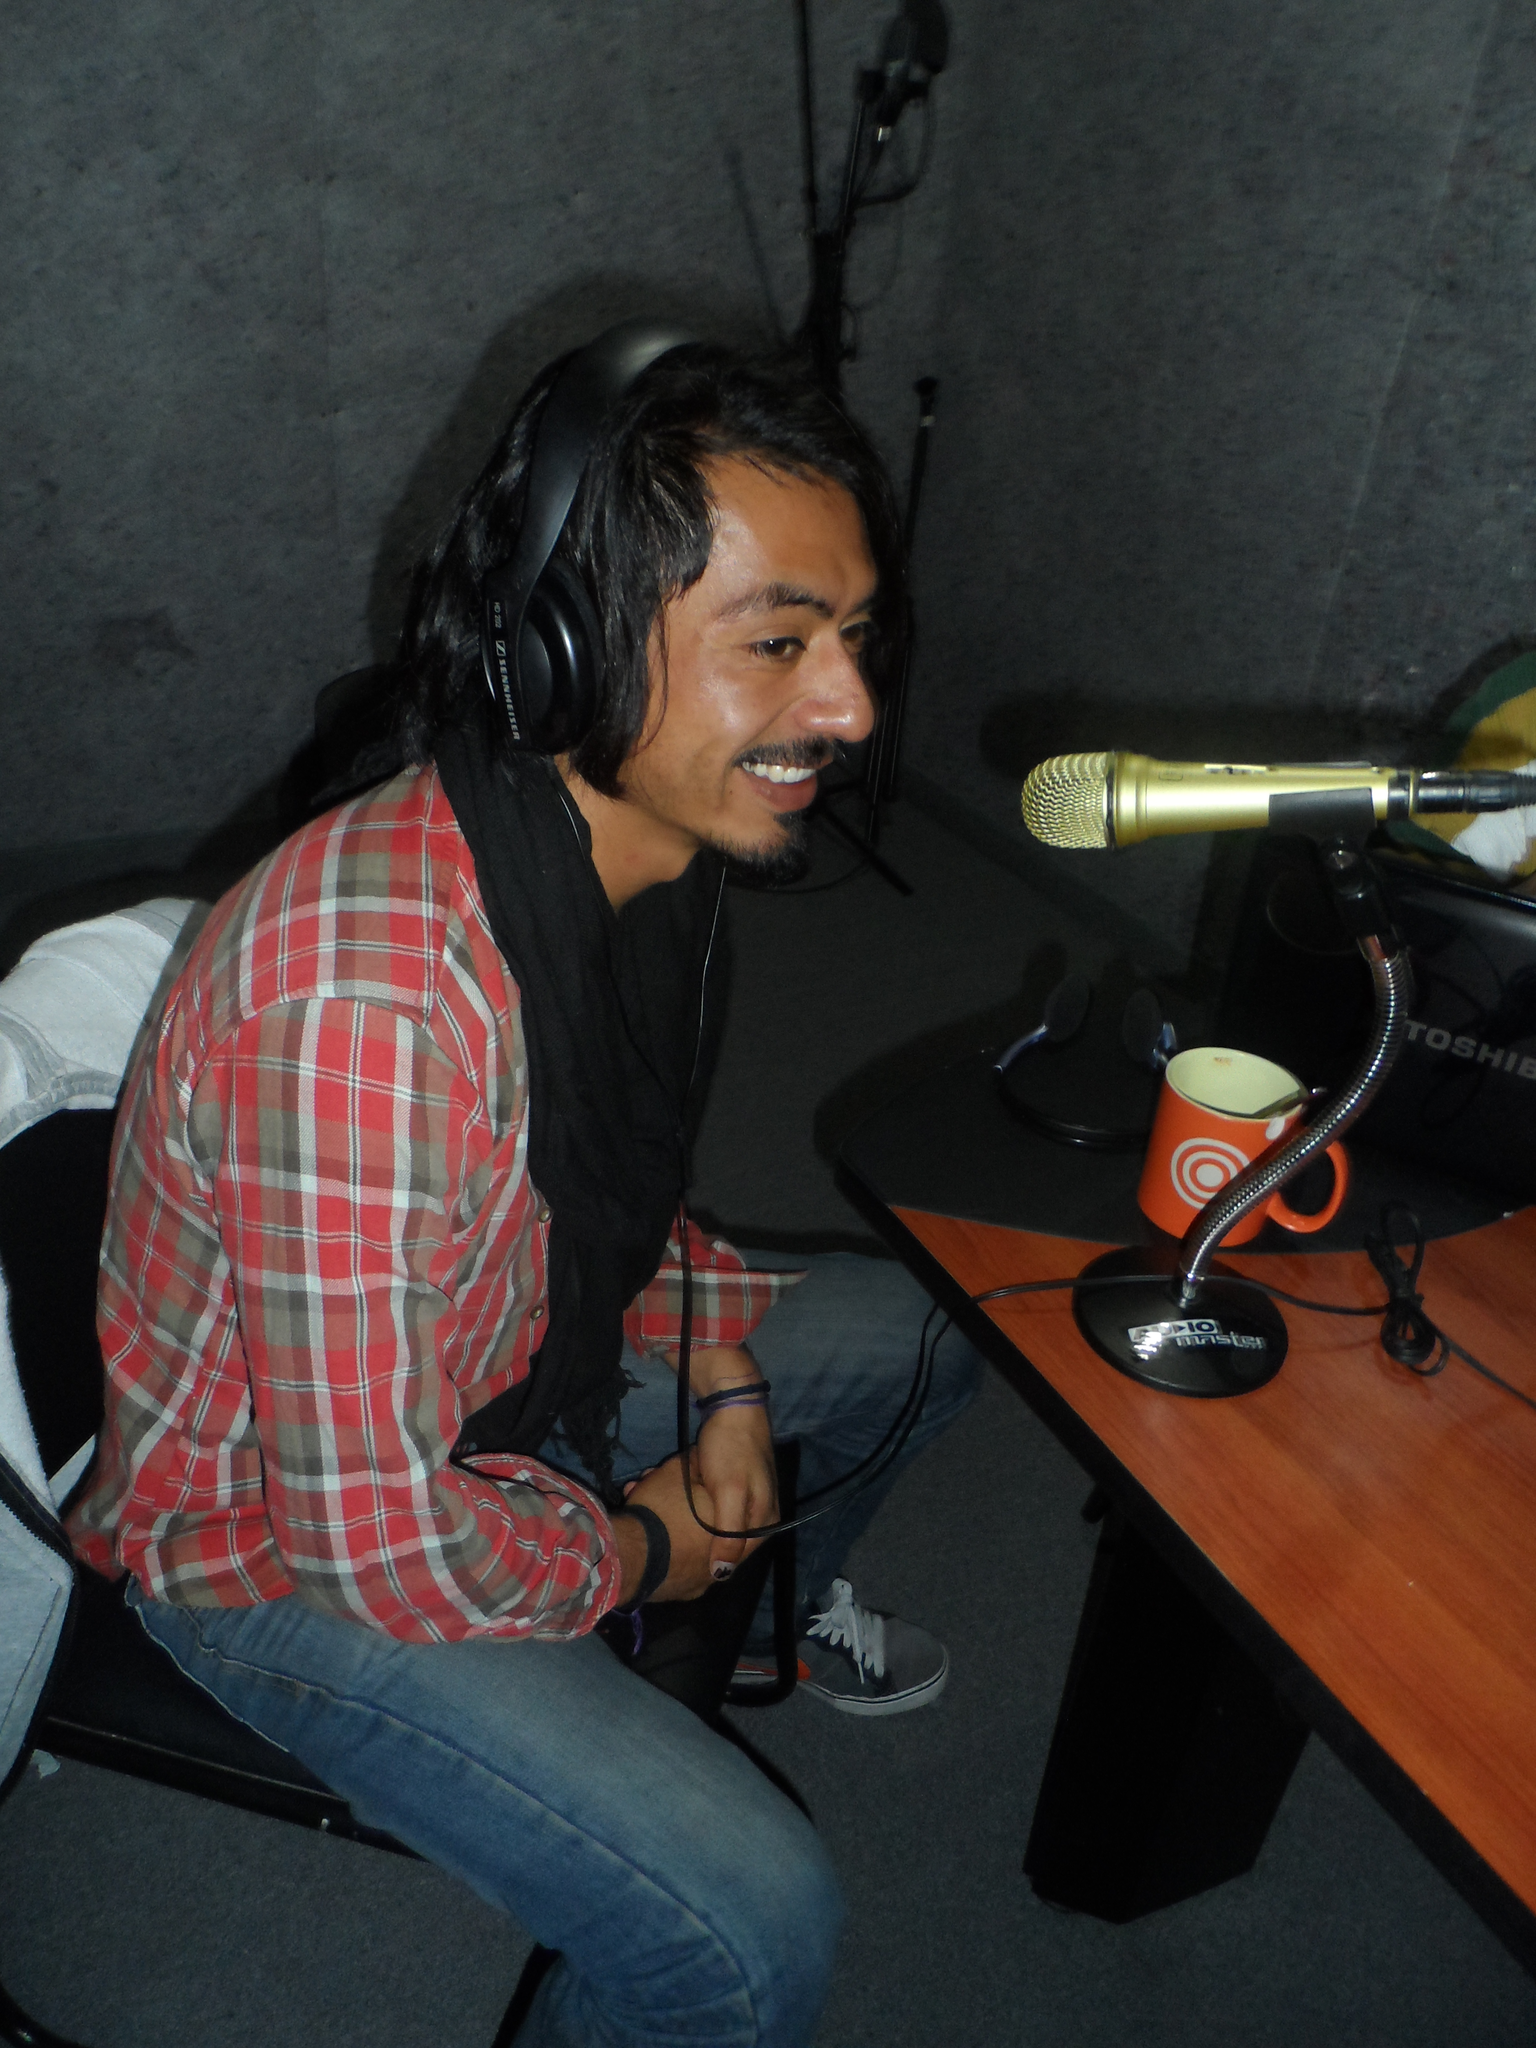Can you describe this image briefly? In this image there is a man who is sitting in a chair is smiling and talking in the microphone which is in the table and there is also a cup and a bag in the table. 